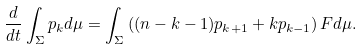Convert formula to latex. <formula><loc_0><loc_0><loc_500><loc_500>\frac { d } { d t } \int _ { \Sigma } p _ { k } d \mu = \int _ { \Sigma } \left ( ( n - k - 1 ) p _ { k + 1 } + k p _ { k - 1 } \right ) F d \mu .</formula> 